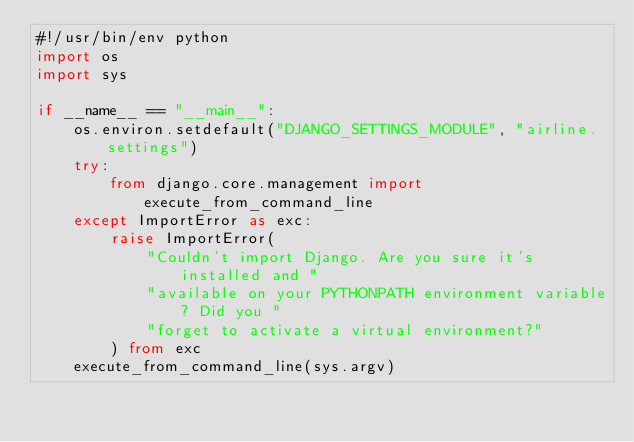Convert code to text. <code><loc_0><loc_0><loc_500><loc_500><_Python_>#!/usr/bin/env python
import os
import sys

if __name__ == "__main__":
    os.environ.setdefault("DJANGO_SETTINGS_MODULE", "airline.settings")
    try:
        from django.core.management import execute_from_command_line
    except ImportError as exc:
        raise ImportError(
            "Couldn't import Django. Are you sure it's installed and "
            "available on your PYTHONPATH environment variable? Did you "
            "forget to activate a virtual environment?"
        ) from exc
    execute_from_command_line(sys.argv)
</code> 